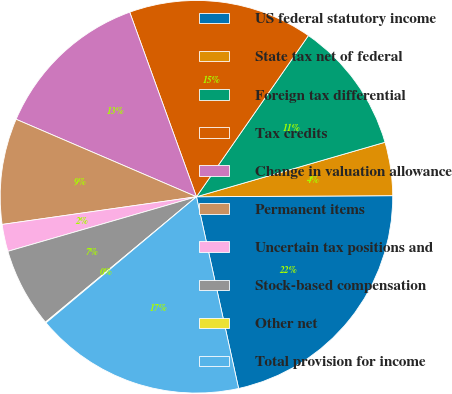Convert chart to OTSL. <chart><loc_0><loc_0><loc_500><loc_500><pie_chart><fcel>US federal statutory income<fcel>State tax net of federal<fcel>Foreign tax differential<fcel>Tax credits<fcel>Change in valuation allowance<fcel>Permanent items<fcel>Uncertain tax positions and<fcel>Stock-based compensation<fcel>Other net<fcel>Total provision for income<nl><fcel>21.64%<fcel>4.39%<fcel>10.86%<fcel>15.18%<fcel>13.02%<fcel>8.71%<fcel>2.23%<fcel>6.55%<fcel>0.07%<fcel>17.34%<nl></chart> 